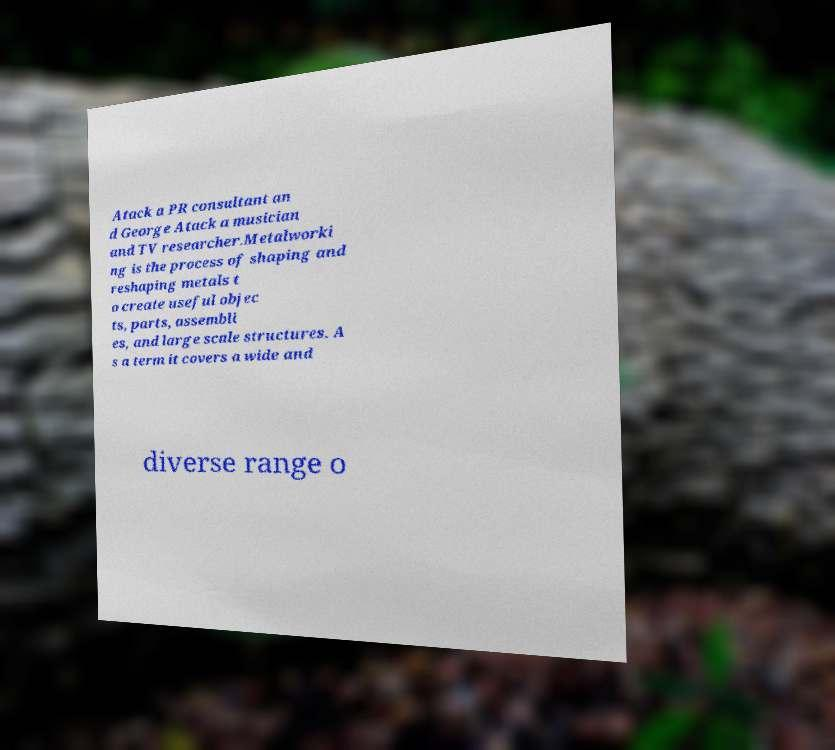There's text embedded in this image that I need extracted. Can you transcribe it verbatim? Atack a PR consultant an d George Atack a musician and TV researcher.Metalworki ng is the process of shaping and reshaping metals t o create useful objec ts, parts, assembli es, and large scale structures. A s a term it covers a wide and diverse range o 